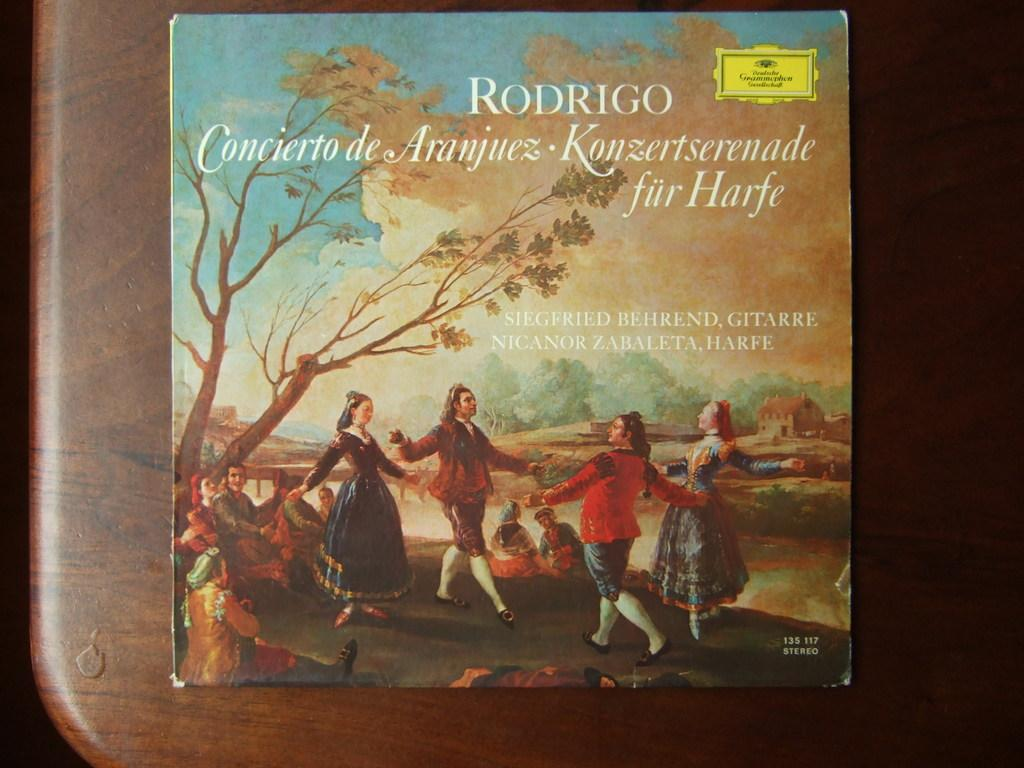<image>
Describe the image concisely. Classical CD named "Rodrigo" placed on top of a wooden table. 